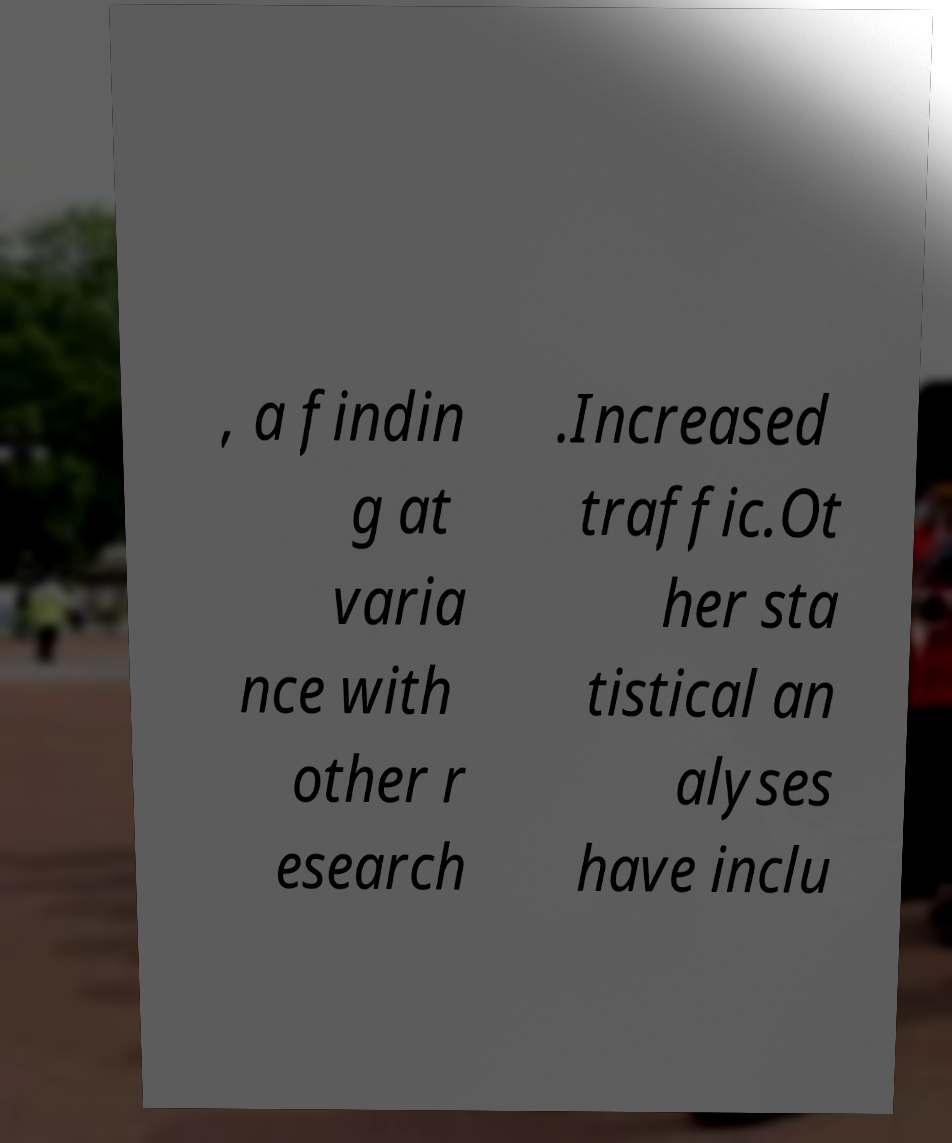For documentation purposes, I need the text within this image transcribed. Could you provide that? , a findin g at varia nce with other r esearch .Increased traffic.Ot her sta tistical an alyses have inclu 